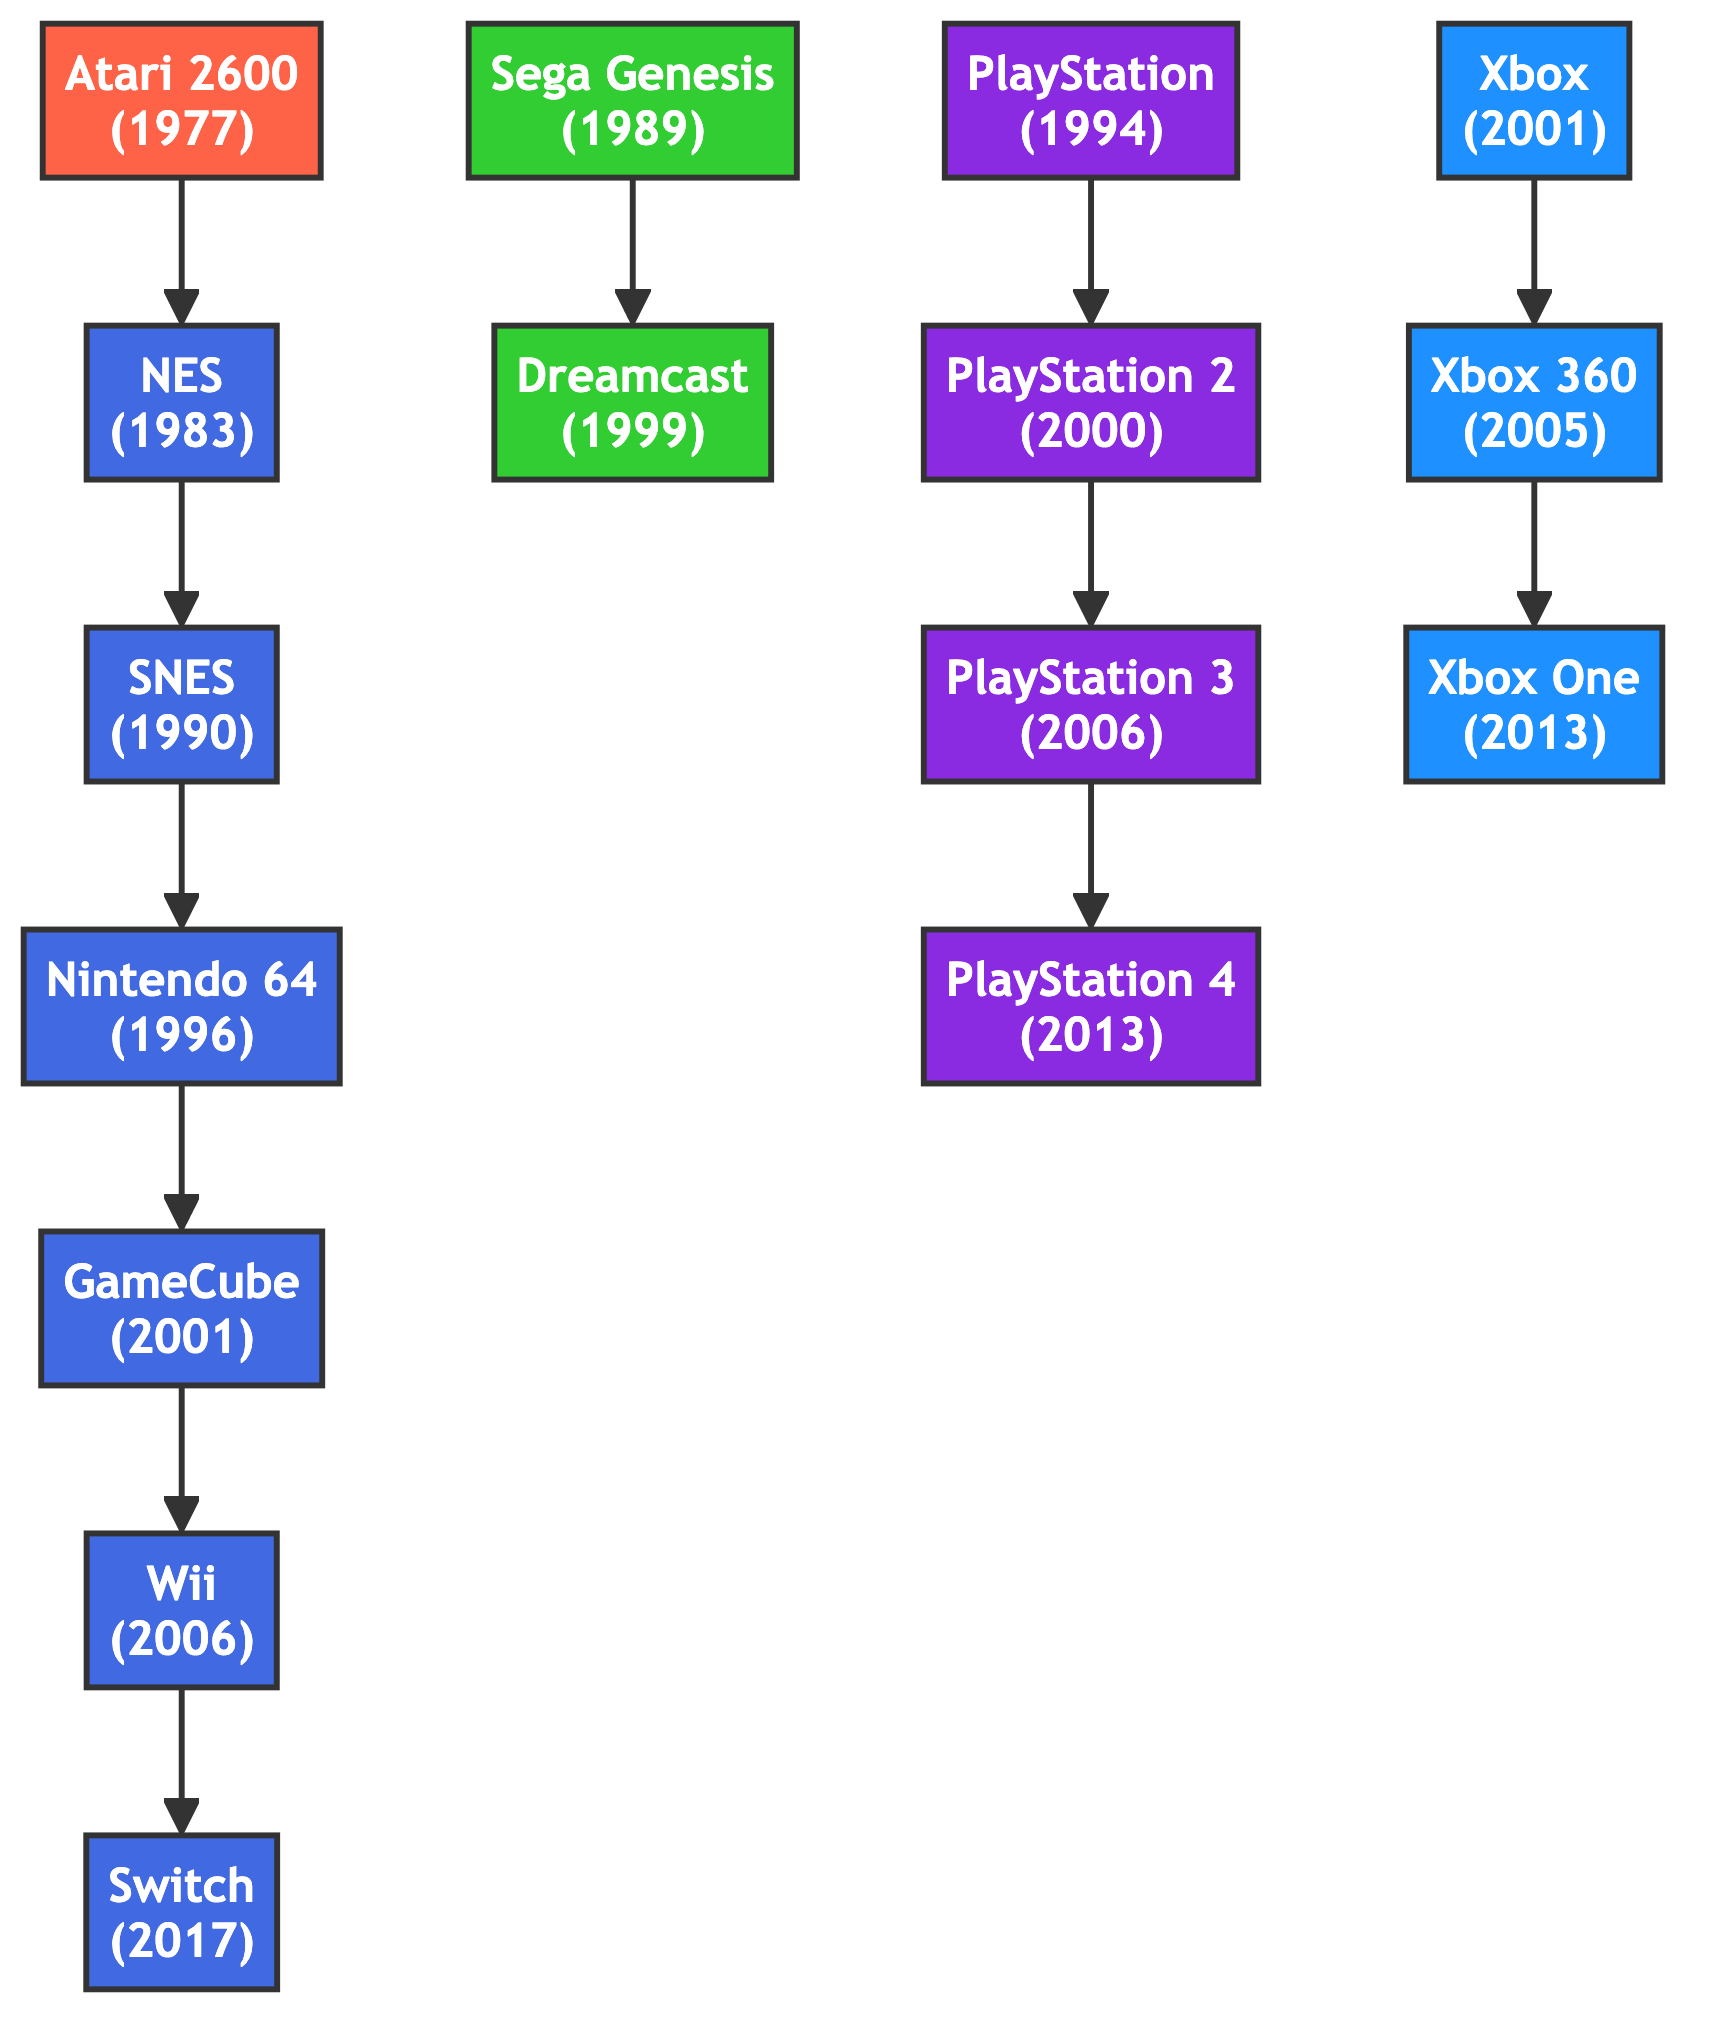What's the release year of the Atari 2600? The Atari 2600 node in the diagram displays the label "Atari 2600" along with the year "(1977)". Thus, the release year shown is 1977.
Answer: 1977 Which console evolved to the Nintendo GameCube? Following the flow in the diagram, the arrow pointing from "Nintendo 64" to "GameCube" indicates that the Nintendo 64 evolved into the GameCube.
Answer: Nintendo 64 How many consoles are shown in this diagram? By counting the "nodes" listed in the data provided, we see there are a total of 15 consoles represented in the diagram.
Answer: 15 Which console preceded the Super Nintendo Entertainment System? Looking at the edge leading to the SNES, the label preceding it is "NES". This indicates that the NES came before the SNES.
Answer: NES What is the relationship between the PlayStation and PlayStation 4? The diagram shows a direct arrow from the PlayStation node to the PlayStation 4 node, indicating that the PlayStation evolved into the PlayStation 2, which in turn evolved through to PlayStation 4. Therefore, the PlayStation 4 is the latest evolution in this chain starting from PlayStation.
Answer: evolved to Which console came after the Xbox 360? Tracing the relationship in the diagram, the edge shows that the Xbox 360 evolved to become the Xbox One. Thus, the Xbox One is the following console.
Answer: Xbox One What color represents Nintendo consoles? In the diagram, the CSS class for Nintendo consoles is defined with the color code #4169E1, which is royal blue. All Nintendo-related nodes are filled with this color.
Answer: blue How are the Sega Genesis and Dreamcast related? The edge shows that the Sega Genesis evolved to become the Dreamcast. This evolution connection is explained by the arrow pointing from the Genesis to the Dreamcast node.
Answer: evolved to Which console group includes the PlayStation and Xbox? By analyzing the nodes, both PlayStation and Xbox belong to the group of consoles produced by their respective companies, Sony and Microsoft. These are grouped distinctively in the diagram by appearance and color. In terms of console groups, they can be classified as separate groups of companies: PlayStation as Sony consoles and Xbox as Microsoft consoles.
Answer: Sony and Microsoft 